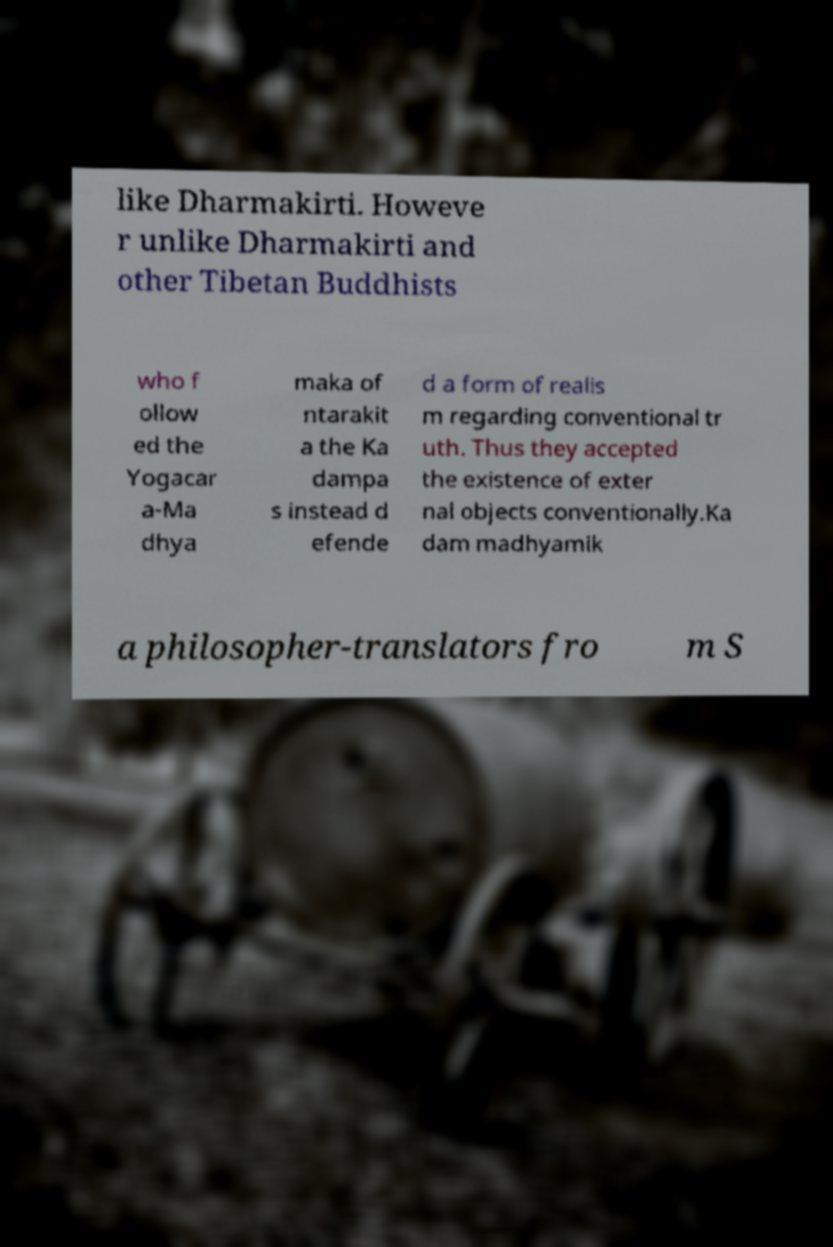Can you accurately transcribe the text from the provided image for me? like Dharmakirti. Howeve r unlike Dharmakirti and other Tibetan Buddhists who f ollow ed the Yogacar a-Ma dhya maka of ntarakit a the Ka dampa s instead d efende d a form of realis m regarding conventional tr uth. Thus they accepted the existence of exter nal objects conventionally.Ka dam madhyamik a philosopher-translators fro m S 